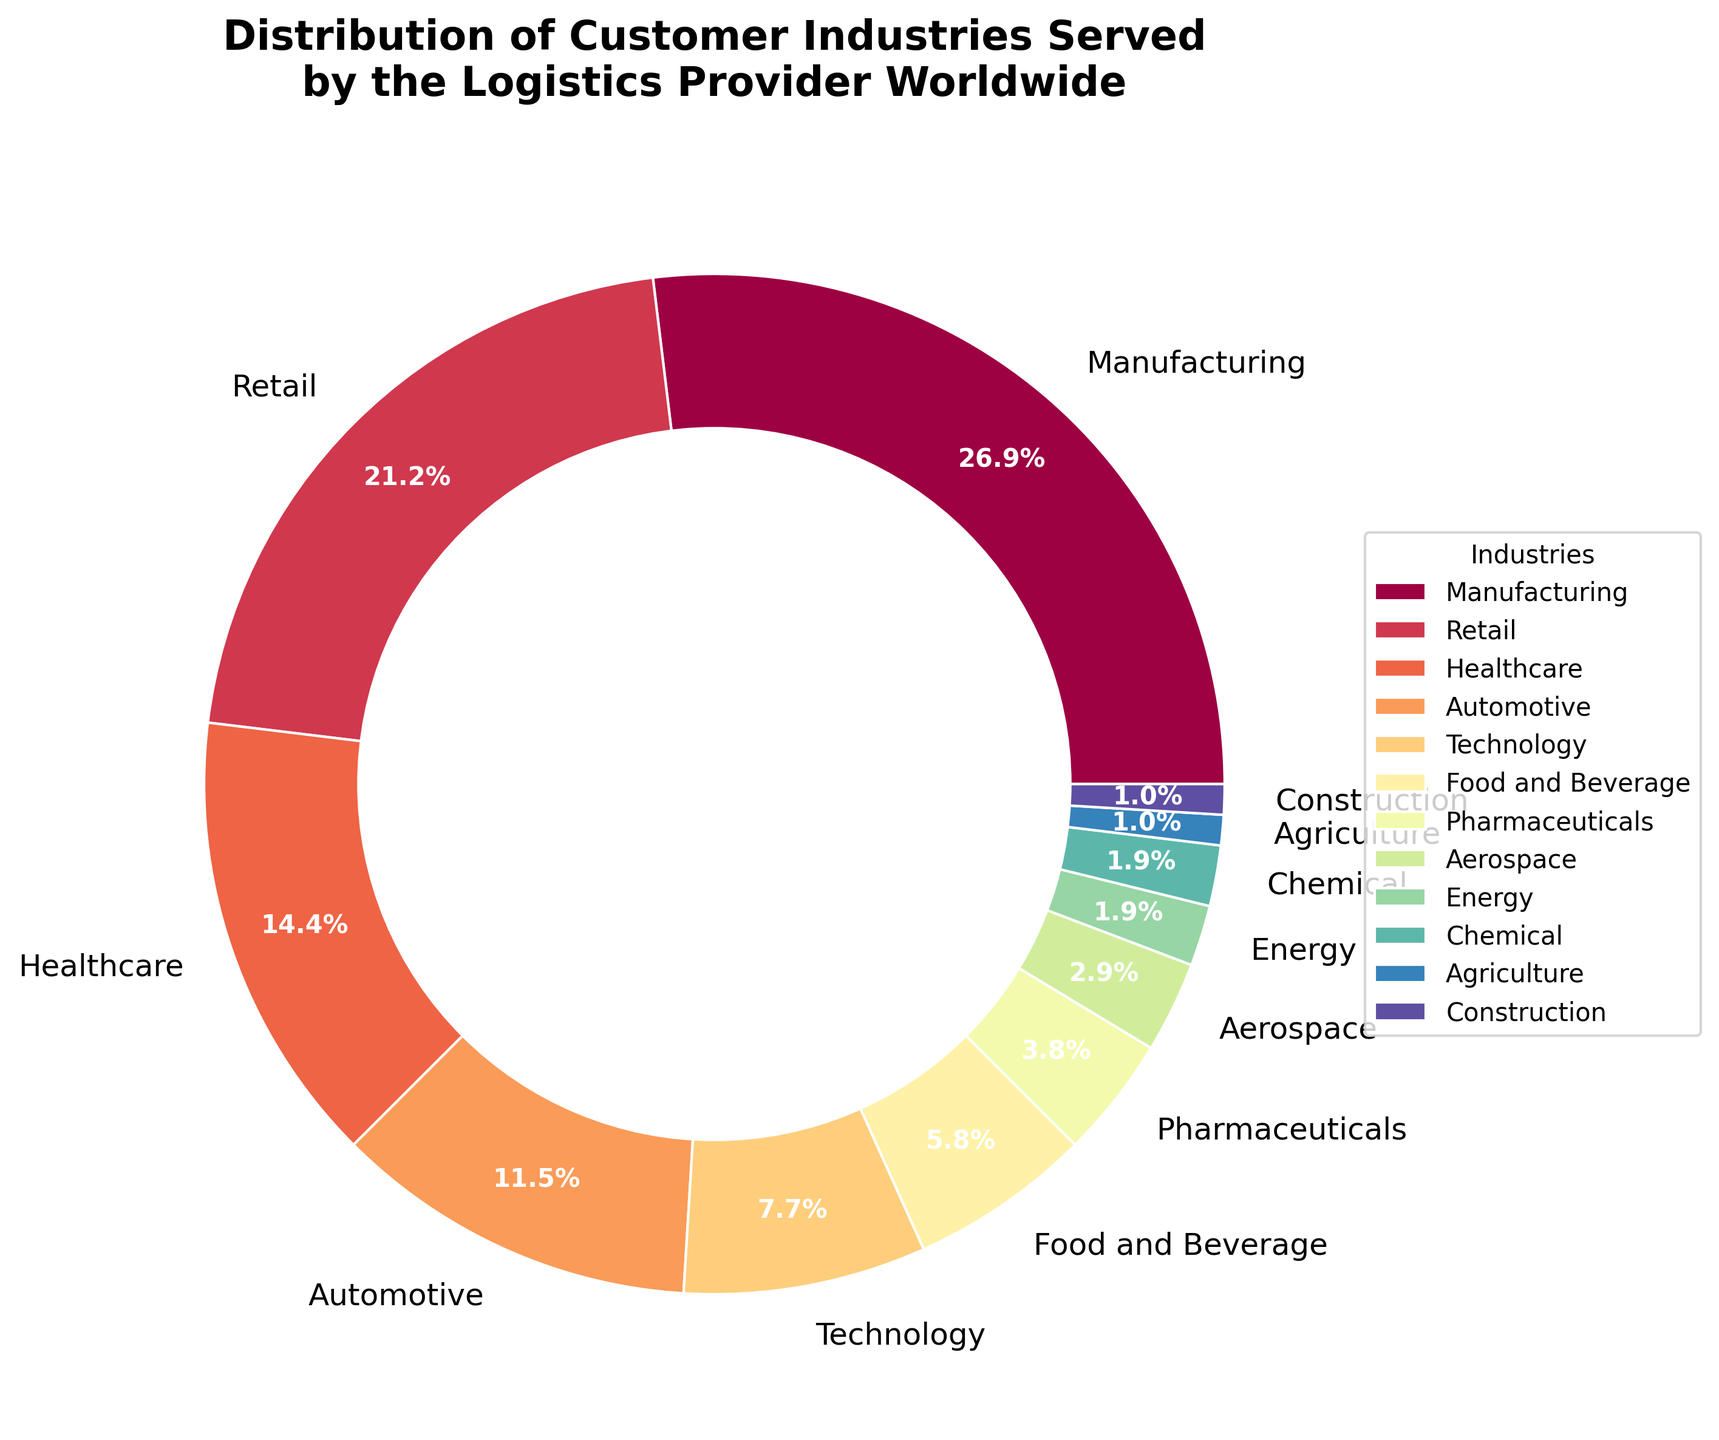What is the largest industry served by the logistics provider? Examine the chart to identify the segment with the largest percentage. The Manufacturing sector has the largest portion at 28%.
Answer: Manufacturing Which two industries have the smallest representation in the pie chart? Identify the smallest segments of the pie chart, which are Agriculture and Construction, each at 1%.
Answer: Agriculture and Construction How much more significant is the Manufacturing sector compared to the Energy sector? Subtract the percentage of the Energy sector (2%) from the Manufacturing sector (28%). The difference is 26%.
Answer: 26% What is the combined percentage of the Technology and Food and Beverage industries? Add the percentages of Technology (8%) and Food and Beverage (6%). The combined percentage is 14%.
Answer: 14% Which industry is represented by a blue segment in the chart? The exact colors are not visible, but if following typical color mapping, a primary color like blue often signifies an important segment like Manufacturing.
Answer: Manufacturing How many industries have a representation of less than 5%? Count the segments labeled with percentages less than 5%. The industries are Pharmaceuticals (4%), Aerospace (3%), Energy (2%), Chemical (2%), Agriculture (1%), and Construction (1%), making six industries in total.
Answer: 6 Is the percentage of the Retail sector greater than that of the Healthcare sector? Compare the percentages of the Retail (22%) and Healthcare (15%) sectors. The Retail sector’s percentage is greater.
Answer: Yes What is the difference between the percentages of the Automotive and Technology sectors? Subtract the Technology sector percentage (8%) from the Automotive sector percentage (12%). The difference is 4%.
Answer: 4% Which sectors, combined, make up more than half of the total distribution? Sum the highest percentages until they exceed 50%. Manufacturing (28%), Retail (22%), and Health Care (15%) add up to 65%, which is more than half.
Answer: Manufacturing, Retail, and Health Care What percentage of the industries served fall into categories other than Manufacturing, Retail, and Healthcare? Subtract the combined percentages of these three sectors (28% + 22% + 15% = 65%) from 100%. The remainder is 35%.
Answer: 35% 